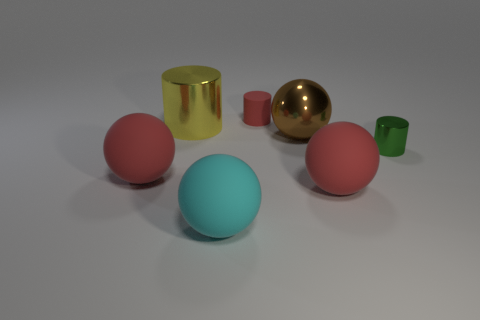What is the shape of the cyan matte object that is the same size as the yellow metallic object?
Make the answer very short. Sphere. What number of other objects are the same material as the brown thing?
Ensure brevity in your answer.  2. Do the small matte cylinder and the large rubber sphere on the left side of the cyan thing have the same color?
Make the answer very short. Yes. Is the number of large red things to the left of the red matte cylinder greater than the number of green cubes?
Provide a succinct answer. Yes. There is a tiny object in front of the red thing that is behind the large brown metallic object; how many red rubber objects are in front of it?
Give a very brief answer. 2. There is a big matte thing that is left of the cyan object; is its shape the same as the cyan rubber thing?
Provide a short and direct response. Yes. There is a large red thing that is right of the big metallic cylinder; what is it made of?
Your answer should be compact. Rubber. What is the shape of the matte thing that is both right of the yellow cylinder and to the left of the small red cylinder?
Make the answer very short. Sphere. What is the material of the large cyan thing?
Provide a short and direct response. Rubber. What number of cubes are big red rubber objects or big shiny things?
Your response must be concise. 0. 